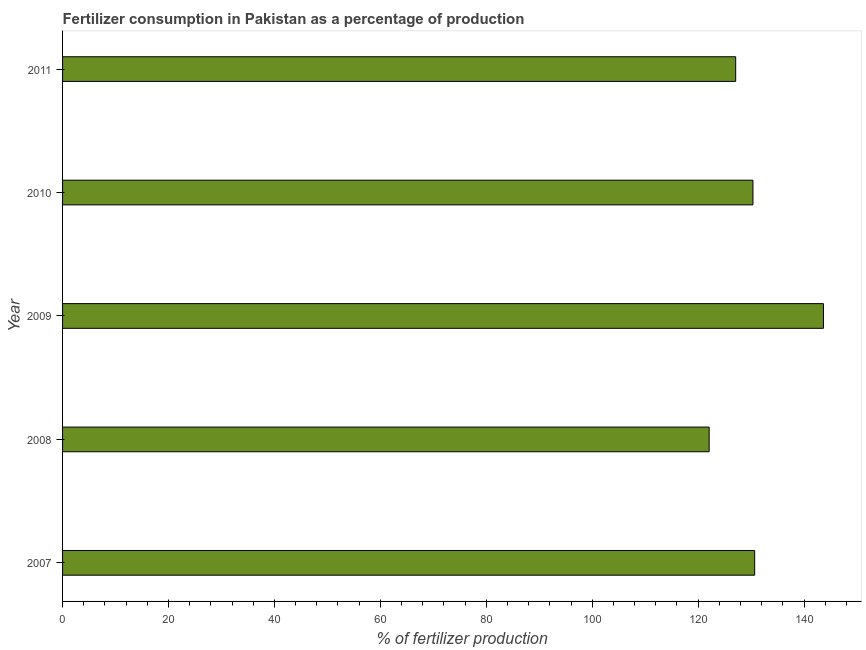Does the graph contain any zero values?
Give a very brief answer. No. What is the title of the graph?
Ensure brevity in your answer.  Fertilizer consumption in Pakistan as a percentage of production. What is the label or title of the X-axis?
Make the answer very short. % of fertilizer production. What is the label or title of the Y-axis?
Your answer should be very brief. Year. What is the amount of fertilizer consumption in 2009?
Make the answer very short. 143.66. Across all years, what is the maximum amount of fertilizer consumption?
Keep it short and to the point. 143.66. Across all years, what is the minimum amount of fertilizer consumption?
Provide a short and direct response. 122.08. In which year was the amount of fertilizer consumption maximum?
Offer a terse response. 2009. What is the sum of the amount of fertilizer consumption?
Make the answer very short. 653.86. What is the difference between the amount of fertilizer consumption in 2009 and 2011?
Offer a terse response. 16.57. What is the average amount of fertilizer consumption per year?
Offer a terse response. 130.77. What is the median amount of fertilizer consumption?
Ensure brevity in your answer.  130.35. Do a majority of the years between 2009 and 2011 (inclusive) have amount of fertilizer consumption greater than 124 %?
Offer a very short reply. Yes. What is the ratio of the amount of fertilizer consumption in 2009 to that in 2011?
Offer a very short reply. 1.13. Is the difference between the amount of fertilizer consumption in 2007 and 2011 greater than the difference between any two years?
Your response must be concise. No. What is the difference between the highest and the second highest amount of fertilizer consumption?
Provide a short and direct response. 12.98. Is the sum of the amount of fertilizer consumption in 2008 and 2010 greater than the maximum amount of fertilizer consumption across all years?
Make the answer very short. Yes. What is the difference between the highest and the lowest amount of fertilizer consumption?
Ensure brevity in your answer.  21.58. In how many years, is the amount of fertilizer consumption greater than the average amount of fertilizer consumption taken over all years?
Offer a terse response. 1. How many years are there in the graph?
Your response must be concise. 5. What is the difference between two consecutive major ticks on the X-axis?
Your answer should be very brief. 20. Are the values on the major ticks of X-axis written in scientific E-notation?
Give a very brief answer. No. What is the % of fertilizer production in 2007?
Make the answer very short. 130.68. What is the % of fertilizer production of 2008?
Provide a short and direct response. 122.08. What is the % of fertilizer production in 2009?
Ensure brevity in your answer.  143.66. What is the % of fertilizer production in 2010?
Ensure brevity in your answer.  130.35. What is the % of fertilizer production of 2011?
Give a very brief answer. 127.09. What is the difference between the % of fertilizer production in 2007 and 2008?
Make the answer very short. 8.59. What is the difference between the % of fertilizer production in 2007 and 2009?
Offer a terse response. -12.99. What is the difference between the % of fertilizer production in 2007 and 2010?
Your answer should be very brief. 0.32. What is the difference between the % of fertilizer production in 2007 and 2011?
Your answer should be very brief. 3.59. What is the difference between the % of fertilizer production in 2008 and 2009?
Keep it short and to the point. -21.58. What is the difference between the % of fertilizer production in 2008 and 2010?
Ensure brevity in your answer.  -8.27. What is the difference between the % of fertilizer production in 2008 and 2011?
Your response must be concise. -5.01. What is the difference between the % of fertilizer production in 2009 and 2010?
Offer a very short reply. 13.31. What is the difference between the % of fertilizer production in 2009 and 2011?
Offer a terse response. 16.57. What is the difference between the % of fertilizer production in 2010 and 2011?
Keep it short and to the point. 3.26. What is the ratio of the % of fertilizer production in 2007 to that in 2008?
Your answer should be very brief. 1.07. What is the ratio of the % of fertilizer production in 2007 to that in 2009?
Your response must be concise. 0.91. What is the ratio of the % of fertilizer production in 2007 to that in 2010?
Keep it short and to the point. 1. What is the ratio of the % of fertilizer production in 2007 to that in 2011?
Your answer should be very brief. 1.03. What is the ratio of the % of fertilizer production in 2008 to that in 2010?
Provide a short and direct response. 0.94. What is the ratio of the % of fertilizer production in 2008 to that in 2011?
Offer a terse response. 0.96. What is the ratio of the % of fertilizer production in 2009 to that in 2010?
Keep it short and to the point. 1.1. What is the ratio of the % of fertilizer production in 2009 to that in 2011?
Offer a very short reply. 1.13. 